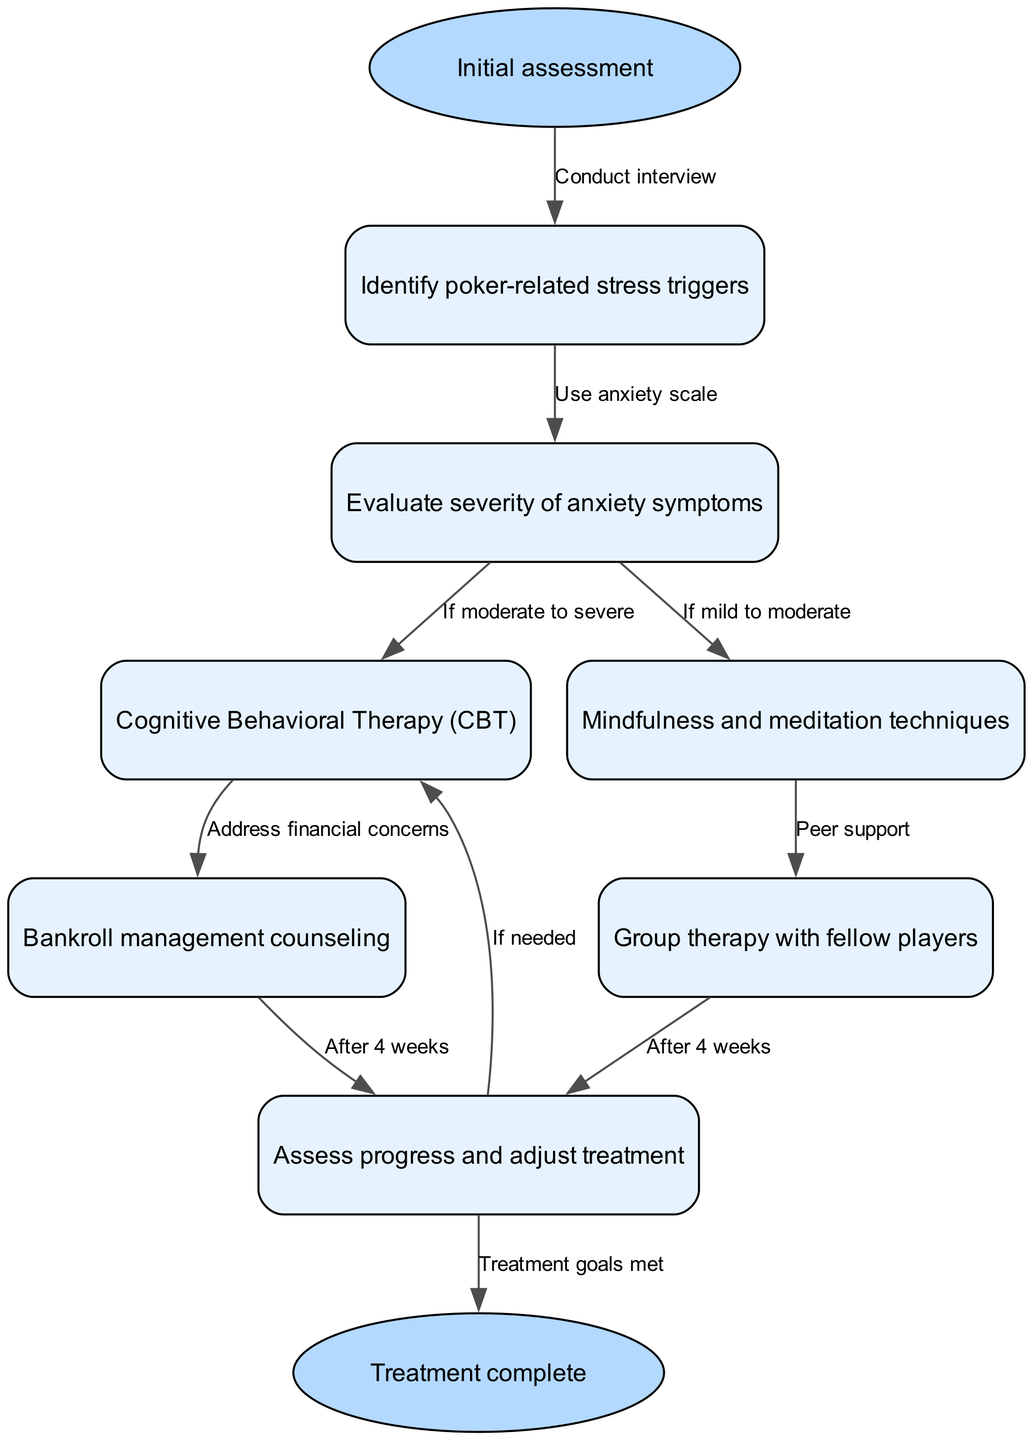What is the first step in the clinical pathway? The first step is the "Initial assessment." This is where the process begins, leading into identifying poker-related stress triggers.
Answer: Initial assessment How many nodes are there in the diagram? By counting the nodes listed in the data, there is a total of seven nodes, including the start and end nodes.
Answer: 7 Which node follows "Evaluate severity of anxiety symptoms"? According to the edges, "Cognitive Behavioral Therapy (CBT)" follows "Evaluate severity of anxiety symptoms" if the symptoms are moderate to severe.
Answer: Cognitive Behavioral Therapy (CBT) What is the focus of the node labeled "5"? The node labeled "5" corresponds to "Bankroll management counseling," which addresses financial concerns related to poker playing.
Answer: Bankroll management counseling What happens after four weeks of "Group therapy with fellow players"? After four weeks of "Group therapy with fellow players," the next step is to "Assess progress and adjust treatment" to determine if additional interventions are needed.
Answer: Assess progress and adjust treatment If someone has mild to moderate anxiety, which treatment option do they proceed to? If anxiety is identified as mild to moderate severity, the next step is to use "Mindfulness and meditation techniques" as a therapeutic approach.
Answer: Mindfulness and meditation techniques What leads to "Treatment complete"? "Treatment complete" is reached after determining that the treatment goals have been met, which is indicated as the final node in the clinical pathway diagram.
Answer: Treatment goals met What is a potential follow-up step after "Cognitive Behavioral Therapy (CBT)"? A potential follow-up after "Cognitive Behavioral Therapy (CBT)" is "Bankroll management counseling" if financial concerns are present, addressing stress related to financial aspects of poker.
Answer: Bankroll management counseling 